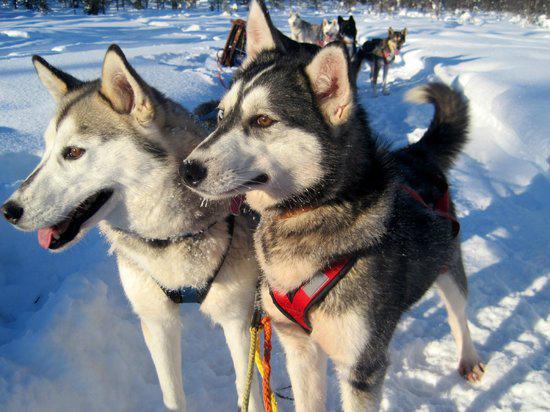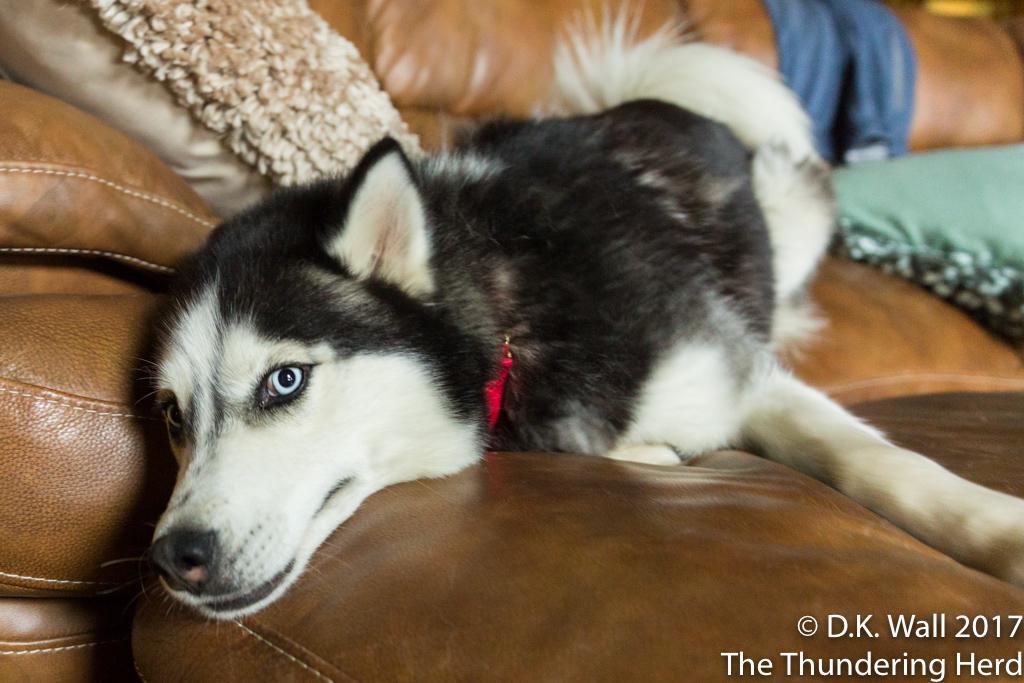The first image is the image on the left, the second image is the image on the right. Analyze the images presented: Is the assertion "The combined images include a dog wearing a bow,  at least one dog sitting upright, at least one dog looking upward, and something red on the floor in front of a dog." valid? Answer yes or no. No. The first image is the image on the left, the second image is the image on the right. Analyze the images presented: Is the assertion "Two dogs are sitting." valid? Answer yes or no. No. 